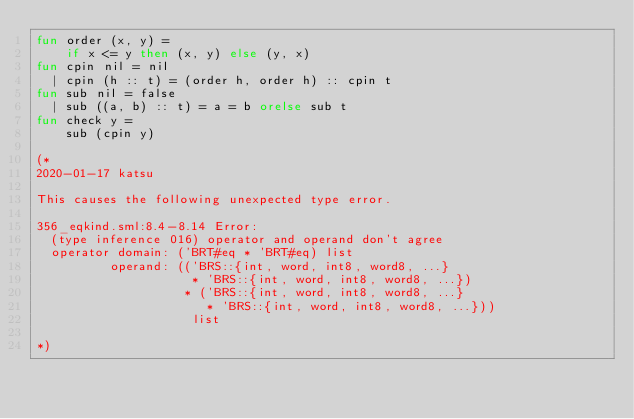Convert code to text. <code><loc_0><loc_0><loc_500><loc_500><_SML_>fun order (x, y) =
    if x <= y then (x, y) else (y, x)
fun cpin nil = nil
  | cpin (h :: t) = (order h, order h) :: cpin t
fun sub nil = false
  | sub ((a, b) :: t) = a = b orelse sub t
fun check y =
    sub (cpin y)

(*
2020-01-17 katsu

This causes the following unexpected type error.

356_eqkind.sml:8.4-8.14 Error:
  (type inference 016) operator and operand don't agree
  operator domain: ('BRT#eq * 'BRT#eq) list
          operand: (('BRS::{int, word, int8, word8, ...}
                     * 'BRS::{int, word, int8, word8, ...})
                    * ('BRS::{int, word, int8, word8, ...}
                       * 'BRS::{int, word, int8, word8, ...}))
                     list

*)
</code> 